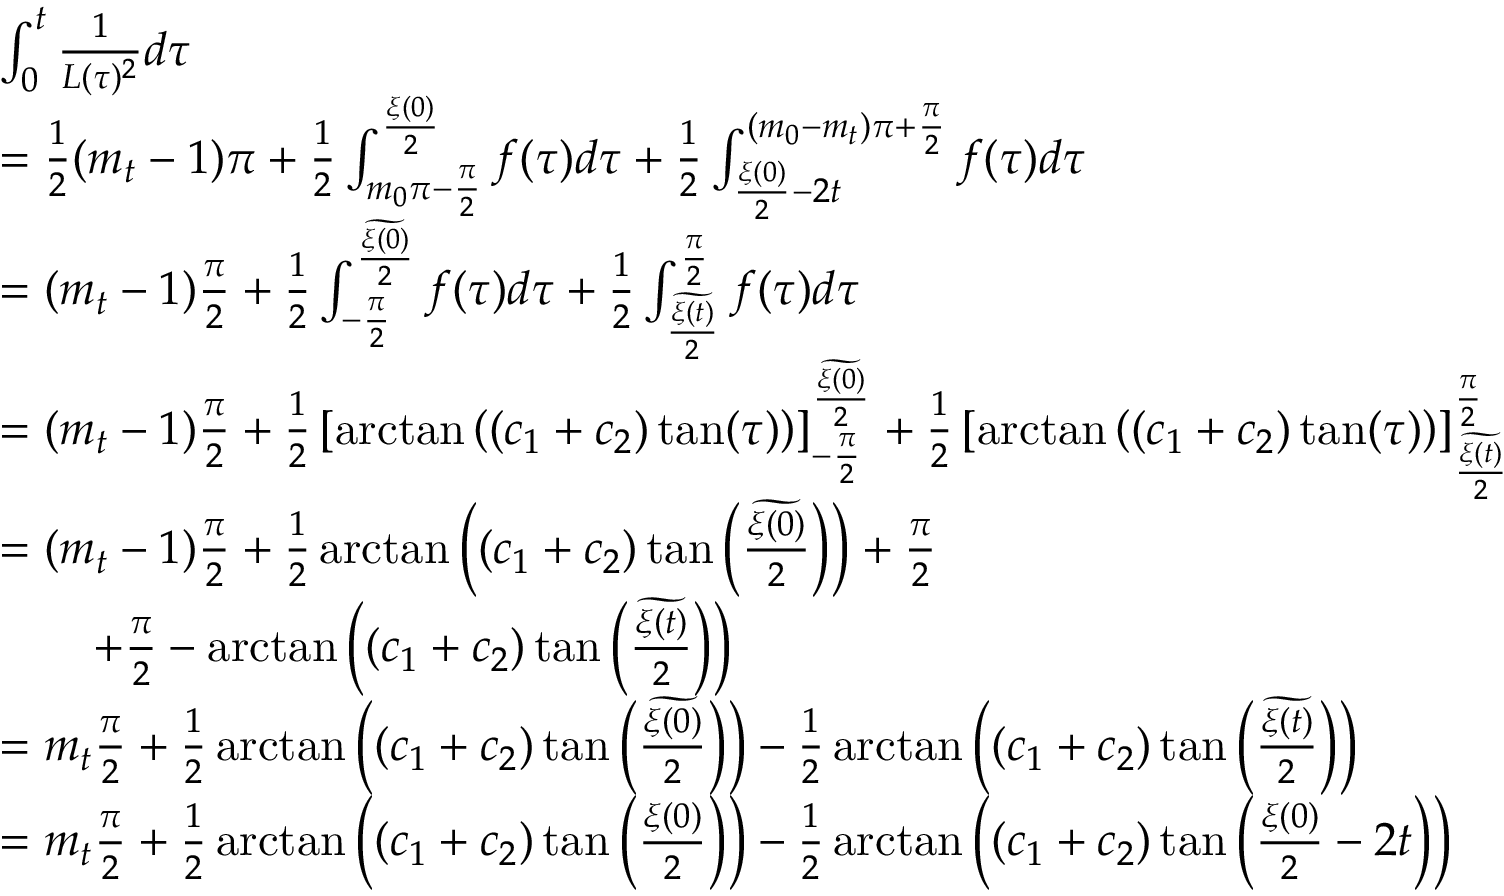<formula> <loc_0><loc_0><loc_500><loc_500>\begin{array} { r l } & { \int _ { 0 } ^ { t } \frac { 1 } { L ( \tau ) ^ { 2 } } d \tau } \\ & { = \frac { 1 } { 2 } ( m _ { t } - 1 ) \pi + \frac { 1 } { 2 } \int _ { m _ { 0 } \pi - \frac { \pi } { 2 } } ^ { \frac { \xi ( 0 ) } { 2 } } f ( \tau ) d \tau + \frac { 1 } { 2 } \int _ { \frac { \xi ( 0 ) } { 2 } - 2 t } ^ { ( m _ { 0 } - m _ { t } ) \pi + \frac { \pi } { 2 } } f ( \tau ) d \tau } \\ & { = ( m _ { t } - 1 ) \frac { \pi } { 2 } + \frac { 1 } { 2 } \int _ { - \frac { \pi } { 2 } } ^ { \frac { \widetilde { \xi ( 0 ) } } { 2 } } f ( \tau ) d \tau + \frac { 1 } { 2 } \int _ { \frac { \widetilde { \xi ( t ) } } { 2 } } ^ { \frac { \pi } { 2 } } f ( \tau ) d \tau } \\ & { = ( m _ { t } - 1 ) \frac { \pi } { 2 } + \frac { 1 } { 2 } \left [ \arctan \left ( ( c _ { 1 } + c _ { 2 } ) \tan ( \tau ) \right ) \right ] _ { - \frac { \pi } { 2 } } ^ { \frac { \widetilde { \xi ( 0 ) } } { 2 } } + \frac { 1 } { 2 } \left [ \arctan \left ( ( c _ { 1 } + c _ { 2 } ) \tan ( \tau ) \right ) \right ] _ { \frac { \widetilde { \xi ( t ) } } { 2 } } ^ { \frac { \pi } { 2 } } } \\ & { = ( m _ { t } - 1 ) \frac { \pi } { 2 } + \frac { 1 } { 2 } \arctan \left ( ( c _ { 1 } + c _ { 2 } ) \tan \left ( \frac { \widetilde { \xi ( 0 ) } } { 2 } \right ) \right ) + \frac { \pi } { 2 } } \\ & { \quad + \frac { \pi } { 2 } - \arctan \left ( ( c _ { 1 } + c _ { 2 } ) \tan \left ( \frac { \widetilde { \xi ( t ) } } { 2 } \right ) \right ) } \\ & { = m _ { t } \frac { \pi } { 2 } + \frac { 1 } { 2 } \arctan \left ( ( c _ { 1 } + c _ { 2 } ) \tan \left ( \frac { \widetilde { \xi ( 0 ) } } { 2 } \right ) \right ) - \frac { 1 } { 2 } \arctan \left ( ( c _ { 1 } + c _ { 2 } ) \tan \left ( \frac { \widetilde { \xi ( t ) } } { 2 } \right ) \right ) } \\ & { = m _ { t } \frac { \pi } { 2 } + \frac { 1 } { 2 } \arctan \left ( ( c _ { 1 } + c _ { 2 } ) \tan \left ( \frac { \xi ( 0 ) } { 2 } \right ) \right ) - \frac { 1 } { 2 } \arctan \left ( ( c _ { 1 } + c _ { 2 } ) \tan \left ( \frac { \xi ( 0 ) } { 2 } - 2 t \right ) \right ) } \end{array}</formula> 